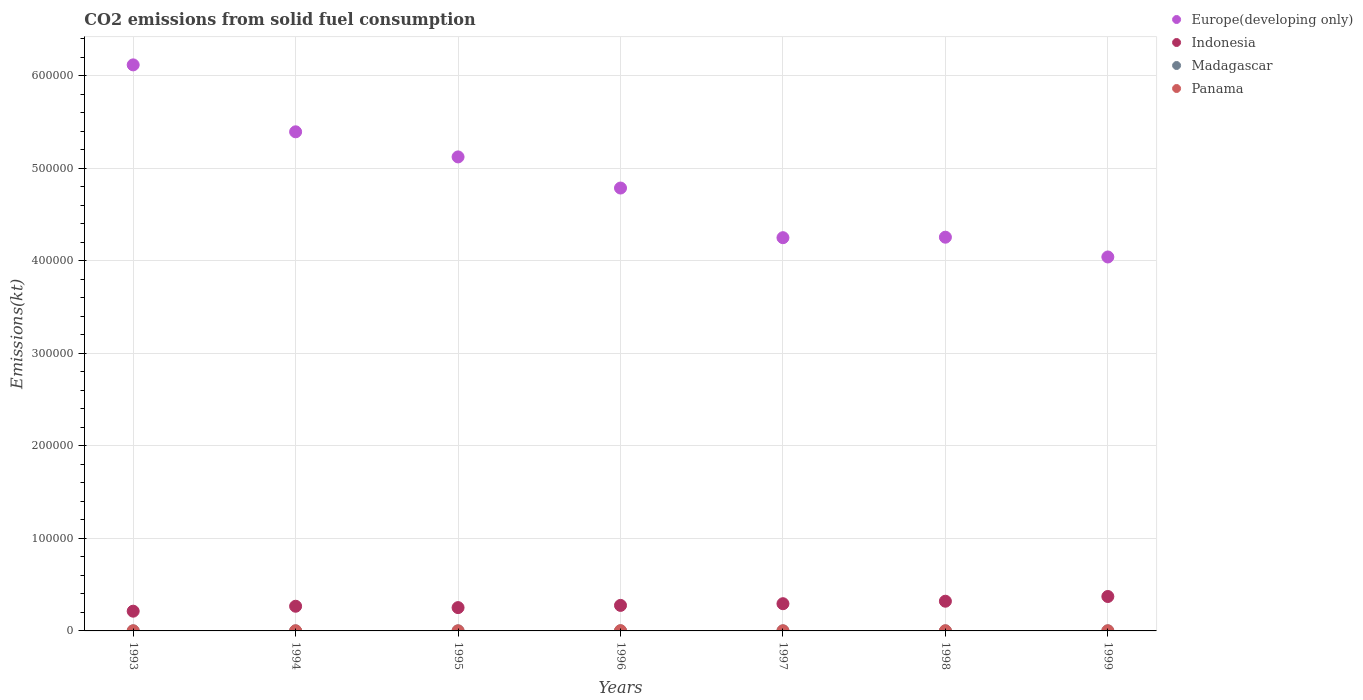How many different coloured dotlines are there?
Provide a succinct answer. 4. Is the number of dotlines equal to the number of legend labels?
Your answer should be compact. Yes. What is the amount of CO2 emitted in Panama in 1997?
Offer a very short reply. 150.35. Across all years, what is the maximum amount of CO2 emitted in Madagascar?
Offer a terse response. 36.67. Across all years, what is the minimum amount of CO2 emitted in Indonesia?
Your answer should be compact. 2.13e+04. In which year was the amount of CO2 emitted in Madagascar maximum?
Keep it short and to the point. 1993. In which year was the amount of CO2 emitted in Europe(developing only) minimum?
Give a very brief answer. 1999. What is the total amount of CO2 emitted in Panama in the graph?
Offer a terse response. 1107.43. What is the difference between the amount of CO2 emitted in Europe(developing only) in 1994 and that in 1999?
Your answer should be compact. 1.35e+05. What is the difference between the amount of CO2 emitted in Panama in 1998 and the amount of CO2 emitted in Europe(developing only) in 1996?
Offer a very short reply. -4.78e+05. What is the average amount of CO2 emitted in Indonesia per year?
Your answer should be compact. 2.85e+04. In the year 1995, what is the difference between the amount of CO2 emitted in Panama and amount of CO2 emitted in Indonesia?
Make the answer very short. -2.51e+04. What is the difference between the highest and the second highest amount of CO2 emitted in Indonesia?
Your answer should be very brief. 5097.13. What is the difference between the highest and the lowest amount of CO2 emitted in Indonesia?
Your answer should be compact. 1.59e+04. In how many years, is the amount of CO2 emitted in Panama greater than the average amount of CO2 emitted in Panama taken over all years?
Your response must be concise. 1. Is the sum of the amount of CO2 emitted in Madagascar in 1996 and 1999 greater than the maximum amount of CO2 emitted in Indonesia across all years?
Offer a terse response. No. Does the amount of CO2 emitted in Panama monotonically increase over the years?
Provide a succinct answer. No. Is the amount of CO2 emitted in Indonesia strictly greater than the amount of CO2 emitted in Madagascar over the years?
Your response must be concise. Yes. How many dotlines are there?
Provide a succinct answer. 4. Does the graph contain grids?
Keep it short and to the point. Yes. Where does the legend appear in the graph?
Ensure brevity in your answer.  Top right. What is the title of the graph?
Your answer should be compact. CO2 emissions from solid fuel consumption. Does "Tonga" appear as one of the legend labels in the graph?
Your answer should be compact. No. What is the label or title of the X-axis?
Your answer should be very brief. Years. What is the label or title of the Y-axis?
Your answer should be compact. Emissions(kt). What is the Emissions(kt) in Europe(developing only) in 1993?
Provide a short and direct response. 6.12e+05. What is the Emissions(kt) of Indonesia in 1993?
Keep it short and to the point. 2.13e+04. What is the Emissions(kt) of Madagascar in 1993?
Ensure brevity in your answer.  36.67. What is the Emissions(kt) of Panama in 1993?
Ensure brevity in your answer.  139.35. What is the Emissions(kt) in Europe(developing only) in 1994?
Provide a short and direct response. 5.39e+05. What is the Emissions(kt) of Indonesia in 1994?
Offer a terse response. 2.67e+04. What is the Emissions(kt) of Madagascar in 1994?
Your answer should be compact. 33. What is the Emissions(kt) in Panama in 1994?
Ensure brevity in your answer.  143.01. What is the Emissions(kt) of Europe(developing only) in 1995?
Offer a terse response. 5.12e+05. What is the Emissions(kt) of Indonesia in 1995?
Ensure brevity in your answer.  2.52e+04. What is the Emissions(kt) of Madagascar in 1995?
Ensure brevity in your answer.  25.67. What is the Emissions(kt) in Panama in 1995?
Ensure brevity in your answer.  95.34. What is the Emissions(kt) of Europe(developing only) in 1996?
Your answer should be compact. 4.79e+05. What is the Emissions(kt) of Indonesia in 1996?
Ensure brevity in your answer.  2.76e+04. What is the Emissions(kt) of Madagascar in 1996?
Make the answer very short. 25.67. What is the Emissions(kt) of Panama in 1996?
Provide a short and direct response. 264.02. What is the Emissions(kt) in Europe(developing only) in 1997?
Your answer should be compact. 4.25e+05. What is the Emissions(kt) in Indonesia in 1997?
Offer a terse response. 2.94e+04. What is the Emissions(kt) in Madagascar in 1997?
Provide a succinct answer. 33. What is the Emissions(kt) in Panama in 1997?
Provide a succinct answer. 150.35. What is the Emissions(kt) of Europe(developing only) in 1998?
Provide a short and direct response. 4.26e+05. What is the Emissions(kt) of Indonesia in 1998?
Offer a very short reply. 3.21e+04. What is the Emissions(kt) of Madagascar in 1998?
Your answer should be very brief. 33. What is the Emissions(kt) of Panama in 1998?
Your answer should be compact. 157.68. What is the Emissions(kt) in Europe(developing only) in 1999?
Keep it short and to the point. 4.04e+05. What is the Emissions(kt) of Indonesia in 1999?
Your answer should be compact. 3.72e+04. What is the Emissions(kt) of Madagascar in 1999?
Offer a terse response. 22. What is the Emissions(kt) of Panama in 1999?
Provide a succinct answer. 157.68. Across all years, what is the maximum Emissions(kt) in Europe(developing only)?
Provide a short and direct response. 6.12e+05. Across all years, what is the maximum Emissions(kt) in Indonesia?
Make the answer very short. 3.72e+04. Across all years, what is the maximum Emissions(kt) in Madagascar?
Keep it short and to the point. 36.67. Across all years, what is the maximum Emissions(kt) in Panama?
Provide a short and direct response. 264.02. Across all years, what is the minimum Emissions(kt) of Europe(developing only)?
Offer a very short reply. 4.04e+05. Across all years, what is the minimum Emissions(kt) of Indonesia?
Give a very brief answer. 2.13e+04. Across all years, what is the minimum Emissions(kt) in Madagascar?
Provide a succinct answer. 22. Across all years, what is the minimum Emissions(kt) in Panama?
Give a very brief answer. 95.34. What is the total Emissions(kt) in Europe(developing only) in the graph?
Offer a terse response. 3.40e+06. What is the total Emissions(kt) of Indonesia in the graph?
Offer a very short reply. 1.99e+05. What is the total Emissions(kt) of Madagascar in the graph?
Offer a terse response. 209.02. What is the total Emissions(kt) in Panama in the graph?
Your response must be concise. 1107.43. What is the difference between the Emissions(kt) of Europe(developing only) in 1993 and that in 1994?
Make the answer very short. 7.23e+04. What is the difference between the Emissions(kt) in Indonesia in 1993 and that in 1994?
Keep it short and to the point. -5342.82. What is the difference between the Emissions(kt) of Madagascar in 1993 and that in 1994?
Provide a succinct answer. 3.67. What is the difference between the Emissions(kt) in Panama in 1993 and that in 1994?
Your response must be concise. -3.67. What is the difference between the Emissions(kt) in Europe(developing only) in 1993 and that in 1995?
Ensure brevity in your answer.  9.95e+04. What is the difference between the Emissions(kt) of Indonesia in 1993 and that in 1995?
Make the answer very short. -3868.68. What is the difference between the Emissions(kt) in Madagascar in 1993 and that in 1995?
Offer a terse response. 11. What is the difference between the Emissions(kt) in Panama in 1993 and that in 1995?
Offer a terse response. 44. What is the difference between the Emissions(kt) in Europe(developing only) in 1993 and that in 1996?
Ensure brevity in your answer.  1.33e+05. What is the difference between the Emissions(kt) of Indonesia in 1993 and that in 1996?
Give a very brief answer. -6255.9. What is the difference between the Emissions(kt) of Madagascar in 1993 and that in 1996?
Your answer should be very brief. 11. What is the difference between the Emissions(kt) in Panama in 1993 and that in 1996?
Give a very brief answer. -124.68. What is the difference between the Emissions(kt) in Europe(developing only) in 1993 and that in 1997?
Your answer should be very brief. 1.87e+05. What is the difference between the Emissions(kt) in Indonesia in 1993 and that in 1997?
Offer a very short reply. -8085.73. What is the difference between the Emissions(kt) of Madagascar in 1993 and that in 1997?
Give a very brief answer. 3.67. What is the difference between the Emissions(kt) of Panama in 1993 and that in 1997?
Your answer should be very brief. -11. What is the difference between the Emissions(kt) in Europe(developing only) in 1993 and that in 1998?
Provide a succinct answer. 1.86e+05. What is the difference between the Emissions(kt) in Indonesia in 1993 and that in 1998?
Keep it short and to the point. -1.08e+04. What is the difference between the Emissions(kt) in Madagascar in 1993 and that in 1998?
Ensure brevity in your answer.  3.67. What is the difference between the Emissions(kt) of Panama in 1993 and that in 1998?
Your answer should be compact. -18.34. What is the difference between the Emissions(kt) in Europe(developing only) in 1993 and that in 1999?
Offer a terse response. 2.08e+05. What is the difference between the Emissions(kt) of Indonesia in 1993 and that in 1999?
Ensure brevity in your answer.  -1.59e+04. What is the difference between the Emissions(kt) in Madagascar in 1993 and that in 1999?
Keep it short and to the point. 14.67. What is the difference between the Emissions(kt) in Panama in 1993 and that in 1999?
Your answer should be very brief. -18.34. What is the difference between the Emissions(kt) in Europe(developing only) in 1994 and that in 1995?
Offer a terse response. 2.71e+04. What is the difference between the Emissions(kt) in Indonesia in 1994 and that in 1995?
Offer a terse response. 1474.13. What is the difference between the Emissions(kt) of Madagascar in 1994 and that in 1995?
Keep it short and to the point. 7.33. What is the difference between the Emissions(kt) of Panama in 1994 and that in 1995?
Keep it short and to the point. 47.67. What is the difference between the Emissions(kt) of Europe(developing only) in 1994 and that in 1996?
Provide a short and direct response. 6.08e+04. What is the difference between the Emissions(kt) in Indonesia in 1994 and that in 1996?
Provide a succinct answer. -913.08. What is the difference between the Emissions(kt) of Madagascar in 1994 and that in 1996?
Ensure brevity in your answer.  7.33. What is the difference between the Emissions(kt) of Panama in 1994 and that in 1996?
Provide a succinct answer. -121.01. What is the difference between the Emissions(kt) of Europe(developing only) in 1994 and that in 1997?
Your response must be concise. 1.14e+05. What is the difference between the Emissions(kt) of Indonesia in 1994 and that in 1997?
Make the answer very short. -2742.92. What is the difference between the Emissions(kt) in Madagascar in 1994 and that in 1997?
Provide a short and direct response. 0. What is the difference between the Emissions(kt) in Panama in 1994 and that in 1997?
Your response must be concise. -7.33. What is the difference between the Emissions(kt) of Europe(developing only) in 1994 and that in 1998?
Keep it short and to the point. 1.14e+05. What is the difference between the Emissions(kt) of Indonesia in 1994 and that in 1998?
Give a very brief answer. -5430.83. What is the difference between the Emissions(kt) in Panama in 1994 and that in 1998?
Make the answer very short. -14.67. What is the difference between the Emissions(kt) of Europe(developing only) in 1994 and that in 1999?
Your answer should be compact. 1.35e+05. What is the difference between the Emissions(kt) of Indonesia in 1994 and that in 1999?
Offer a very short reply. -1.05e+04. What is the difference between the Emissions(kt) of Madagascar in 1994 and that in 1999?
Give a very brief answer. 11. What is the difference between the Emissions(kt) of Panama in 1994 and that in 1999?
Give a very brief answer. -14.67. What is the difference between the Emissions(kt) in Europe(developing only) in 1995 and that in 1996?
Keep it short and to the point. 3.36e+04. What is the difference between the Emissions(kt) in Indonesia in 1995 and that in 1996?
Make the answer very short. -2387.22. What is the difference between the Emissions(kt) of Madagascar in 1995 and that in 1996?
Your answer should be very brief. 0. What is the difference between the Emissions(kt) of Panama in 1995 and that in 1996?
Keep it short and to the point. -168.68. What is the difference between the Emissions(kt) in Europe(developing only) in 1995 and that in 1997?
Make the answer very short. 8.73e+04. What is the difference between the Emissions(kt) in Indonesia in 1995 and that in 1997?
Provide a succinct answer. -4217.05. What is the difference between the Emissions(kt) of Madagascar in 1995 and that in 1997?
Ensure brevity in your answer.  -7.33. What is the difference between the Emissions(kt) of Panama in 1995 and that in 1997?
Give a very brief answer. -55.01. What is the difference between the Emissions(kt) in Europe(developing only) in 1995 and that in 1998?
Offer a terse response. 8.68e+04. What is the difference between the Emissions(kt) of Indonesia in 1995 and that in 1998?
Make the answer very short. -6904.96. What is the difference between the Emissions(kt) of Madagascar in 1995 and that in 1998?
Your answer should be very brief. -7.33. What is the difference between the Emissions(kt) in Panama in 1995 and that in 1998?
Provide a succinct answer. -62.34. What is the difference between the Emissions(kt) of Europe(developing only) in 1995 and that in 1999?
Offer a very short reply. 1.08e+05. What is the difference between the Emissions(kt) of Indonesia in 1995 and that in 1999?
Your response must be concise. -1.20e+04. What is the difference between the Emissions(kt) of Madagascar in 1995 and that in 1999?
Ensure brevity in your answer.  3.67. What is the difference between the Emissions(kt) of Panama in 1995 and that in 1999?
Make the answer very short. -62.34. What is the difference between the Emissions(kt) of Europe(developing only) in 1996 and that in 1997?
Your answer should be compact. 5.37e+04. What is the difference between the Emissions(kt) in Indonesia in 1996 and that in 1997?
Offer a very short reply. -1829.83. What is the difference between the Emissions(kt) in Madagascar in 1996 and that in 1997?
Make the answer very short. -7.33. What is the difference between the Emissions(kt) of Panama in 1996 and that in 1997?
Provide a succinct answer. 113.68. What is the difference between the Emissions(kt) in Europe(developing only) in 1996 and that in 1998?
Your answer should be compact. 5.31e+04. What is the difference between the Emissions(kt) of Indonesia in 1996 and that in 1998?
Your response must be concise. -4517.74. What is the difference between the Emissions(kt) of Madagascar in 1996 and that in 1998?
Provide a succinct answer. -7.33. What is the difference between the Emissions(kt) of Panama in 1996 and that in 1998?
Keep it short and to the point. 106.34. What is the difference between the Emissions(kt) of Europe(developing only) in 1996 and that in 1999?
Keep it short and to the point. 7.45e+04. What is the difference between the Emissions(kt) of Indonesia in 1996 and that in 1999?
Provide a succinct answer. -9614.87. What is the difference between the Emissions(kt) in Madagascar in 1996 and that in 1999?
Your answer should be very brief. 3.67. What is the difference between the Emissions(kt) of Panama in 1996 and that in 1999?
Provide a short and direct response. 106.34. What is the difference between the Emissions(kt) in Europe(developing only) in 1997 and that in 1998?
Make the answer very short. -528.25. What is the difference between the Emissions(kt) of Indonesia in 1997 and that in 1998?
Offer a very short reply. -2687.91. What is the difference between the Emissions(kt) of Panama in 1997 and that in 1998?
Offer a very short reply. -7.33. What is the difference between the Emissions(kt) of Europe(developing only) in 1997 and that in 1999?
Offer a terse response. 2.09e+04. What is the difference between the Emissions(kt) of Indonesia in 1997 and that in 1999?
Ensure brevity in your answer.  -7785.04. What is the difference between the Emissions(kt) of Madagascar in 1997 and that in 1999?
Keep it short and to the point. 11. What is the difference between the Emissions(kt) of Panama in 1997 and that in 1999?
Keep it short and to the point. -7.33. What is the difference between the Emissions(kt) of Europe(developing only) in 1998 and that in 1999?
Offer a terse response. 2.14e+04. What is the difference between the Emissions(kt) in Indonesia in 1998 and that in 1999?
Keep it short and to the point. -5097.13. What is the difference between the Emissions(kt) in Madagascar in 1998 and that in 1999?
Ensure brevity in your answer.  11. What is the difference between the Emissions(kt) of Panama in 1998 and that in 1999?
Your response must be concise. 0. What is the difference between the Emissions(kt) in Europe(developing only) in 1993 and the Emissions(kt) in Indonesia in 1994?
Make the answer very short. 5.85e+05. What is the difference between the Emissions(kt) in Europe(developing only) in 1993 and the Emissions(kt) in Madagascar in 1994?
Your answer should be very brief. 6.12e+05. What is the difference between the Emissions(kt) in Europe(developing only) in 1993 and the Emissions(kt) in Panama in 1994?
Your response must be concise. 6.12e+05. What is the difference between the Emissions(kt) of Indonesia in 1993 and the Emissions(kt) of Madagascar in 1994?
Your answer should be very brief. 2.13e+04. What is the difference between the Emissions(kt) in Indonesia in 1993 and the Emissions(kt) in Panama in 1994?
Keep it short and to the point. 2.12e+04. What is the difference between the Emissions(kt) of Madagascar in 1993 and the Emissions(kt) of Panama in 1994?
Make the answer very short. -106.34. What is the difference between the Emissions(kt) in Europe(developing only) in 1993 and the Emissions(kt) in Indonesia in 1995?
Ensure brevity in your answer.  5.87e+05. What is the difference between the Emissions(kt) of Europe(developing only) in 1993 and the Emissions(kt) of Madagascar in 1995?
Ensure brevity in your answer.  6.12e+05. What is the difference between the Emissions(kt) of Europe(developing only) in 1993 and the Emissions(kt) of Panama in 1995?
Offer a very short reply. 6.12e+05. What is the difference between the Emissions(kt) in Indonesia in 1993 and the Emissions(kt) in Madagascar in 1995?
Give a very brief answer. 2.13e+04. What is the difference between the Emissions(kt) of Indonesia in 1993 and the Emissions(kt) of Panama in 1995?
Ensure brevity in your answer.  2.12e+04. What is the difference between the Emissions(kt) of Madagascar in 1993 and the Emissions(kt) of Panama in 1995?
Offer a terse response. -58.67. What is the difference between the Emissions(kt) in Europe(developing only) in 1993 and the Emissions(kt) in Indonesia in 1996?
Offer a very short reply. 5.84e+05. What is the difference between the Emissions(kt) of Europe(developing only) in 1993 and the Emissions(kt) of Madagascar in 1996?
Provide a succinct answer. 6.12e+05. What is the difference between the Emissions(kt) in Europe(developing only) in 1993 and the Emissions(kt) in Panama in 1996?
Keep it short and to the point. 6.11e+05. What is the difference between the Emissions(kt) of Indonesia in 1993 and the Emissions(kt) of Madagascar in 1996?
Make the answer very short. 2.13e+04. What is the difference between the Emissions(kt) in Indonesia in 1993 and the Emissions(kt) in Panama in 1996?
Keep it short and to the point. 2.11e+04. What is the difference between the Emissions(kt) in Madagascar in 1993 and the Emissions(kt) in Panama in 1996?
Ensure brevity in your answer.  -227.35. What is the difference between the Emissions(kt) of Europe(developing only) in 1993 and the Emissions(kt) of Indonesia in 1997?
Your answer should be compact. 5.82e+05. What is the difference between the Emissions(kt) in Europe(developing only) in 1993 and the Emissions(kt) in Madagascar in 1997?
Give a very brief answer. 6.12e+05. What is the difference between the Emissions(kt) in Europe(developing only) in 1993 and the Emissions(kt) in Panama in 1997?
Ensure brevity in your answer.  6.12e+05. What is the difference between the Emissions(kt) in Indonesia in 1993 and the Emissions(kt) in Madagascar in 1997?
Ensure brevity in your answer.  2.13e+04. What is the difference between the Emissions(kt) of Indonesia in 1993 and the Emissions(kt) of Panama in 1997?
Offer a terse response. 2.12e+04. What is the difference between the Emissions(kt) of Madagascar in 1993 and the Emissions(kt) of Panama in 1997?
Make the answer very short. -113.68. What is the difference between the Emissions(kt) of Europe(developing only) in 1993 and the Emissions(kt) of Indonesia in 1998?
Your response must be concise. 5.80e+05. What is the difference between the Emissions(kt) of Europe(developing only) in 1993 and the Emissions(kt) of Madagascar in 1998?
Give a very brief answer. 6.12e+05. What is the difference between the Emissions(kt) in Europe(developing only) in 1993 and the Emissions(kt) in Panama in 1998?
Ensure brevity in your answer.  6.12e+05. What is the difference between the Emissions(kt) in Indonesia in 1993 and the Emissions(kt) in Madagascar in 1998?
Ensure brevity in your answer.  2.13e+04. What is the difference between the Emissions(kt) in Indonesia in 1993 and the Emissions(kt) in Panama in 1998?
Provide a succinct answer. 2.12e+04. What is the difference between the Emissions(kt) in Madagascar in 1993 and the Emissions(kt) in Panama in 1998?
Provide a short and direct response. -121.01. What is the difference between the Emissions(kt) in Europe(developing only) in 1993 and the Emissions(kt) in Indonesia in 1999?
Provide a succinct answer. 5.75e+05. What is the difference between the Emissions(kt) in Europe(developing only) in 1993 and the Emissions(kt) in Madagascar in 1999?
Offer a very short reply. 6.12e+05. What is the difference between the Emissions(kt) of Europe(developing only) in 1993 and the Emissions(kt) of Panama in 1999?
Provide a succinct answer. 6.12e+05. What is the difference between the Emissions(kt) in Indonesia in 1993 and the Emissions(kt) in Madagascar in 1999?
Your response must be concise. 2.13e+04. What is the difference between the Emissions(kt) of Indonesia in 1993 and the Emissions(kt) of Panama in 1999?
Your response must be concise. 2.12e+04. What is the difference between the Emissions(kt) in Madagascar in 1993 and the Emissions(kt) in Panama in 1999?
Your answer should be compact. -121.01. What is the difference between the Emissions(kt) in Europe(developing only) in 1994 and the Emissions(kt) in Indonesia in 1995?
Offer a very short reply. 5.14e+05. What is the difference between the Emissions(kt) of Europe(developing only) in 1994 and the Emissions(kt) of Madagascar in 1995?
Provide a succinct answer. 5.39e+05. What is the difference between the Emissions(kt) in Europe(developing only) in 1994 and the Emissions(kt) in Panama in 1995?
Give a very brief answer. 5.39e+05. What is the difference between the Emissions(kt) of Indonesia in 1994 and the Emissions(kt) of Madagascar in 1995?
Ensure brevity in your answer.  2.66e+04. What is the difference between the Emissions(kt) in Indonesia in 1994 and the Emissions(kt) in Panama in 1995?
Your answer should be very brief. 2.66e+04. What is the difference between the Emissions(kt) of Madagascar in 1994 and the Emissions(kt) of Panama in 1995?
Keep it short and to the point. -62.34. What is the difference between the Emissions(kt) in Europe(developing only) in 1994 and the Emissions(kt) in Indonesia in 1996?
Ensure brevity in your answer.  5.12e+05. What is the difference between the Emissions(kt) of Europe(developing only) in 1994 and the Emissions(kt) of Madagascar in 1996?
Give a very brief answer. 5.39e+05. What is the difference between the Emissions(kt) in Europe(developing only) in 1994 and the Emissions(kt) in Panama in 1996?
Your answer should be very brief. 5.39e+05. What is the difference between the Emissions(kt) in Indonesia in 1994 and the Emissions(kt) in Madagascar in 1996?
Make the answer very short. 2.66e+04. What is the difference between the Emissions(kt) of Indonesia in 1994 and the Emissions(kt) of Panama in 1996?
Offer a very short reply. 2.64e+04. What is the difference between the Emissions(kt) of Madagascar in 1994 and the Emissions(kt) of Panama in 1996?
Make the answer very short. -231.02. What is the difference between the Emissions(kt) in Europe(developing only) in 1994 and the Emissions(kt) in Indonesia in 1997?
Give a very brief answer. 5.10e+05. What is the difference between the Emissions(kt) in Europe(developing only) in 1994 and the Emissions(kt) in Madagascar in 1997?
Ensure brevity in your answer.  5.39e+05. What is the difference between the Emissions(kt) in Europe(developing only) in 1994 and the Emissions(kt) in Panama in 1997?
Offer a terse response. 5.39e+05. What is the difference between the Emissions(kt) of Indonesia in 1994 and the Emissions(kt) of Madagascar in 1997?
Provide a short and direct response. 2.66e+04. What is the difference between the Emissions(kt) in Indonesia in 1994 and the Emissions(kt) in Panama in 1997?
Provide a short and direct response. 2.65e+04. What is the difference between the Emissions(kt) in Madagascar in 1994 and the Emissions(kt) in Panama in 1997?
Provide a succinct answer. -117.34. What is the difference between the Emissions(kt) of Europe(developing only) in 1994 and the Emissions(kt) of Indonesia in 1998?
Give a very brief answer. 5.07e+05. What is the difference between the Emissions(kt) in Europe(developing only) in 1994 and the Emissions(kt) in Madagascar in 1998?
Keep it short and to the point. 5.39e+05. What is the difference between the Emissions(kt) in Europe(developing only) in 1994 and the Emissions(kt) in Panama in 1998?
Offer a very short reply. 5.39e+05. What is the difference between the Emissions(kt) of Indonesia in 1994 and the Emissions(kt) of Madagascar in 1998?
Provide a short and direct response. 2.66e+04. What is the difference between the Emissions(kt) of Indonesia in 1994 and the Emissions(kt) of Panama in 1998?
Offer a very short reply. 2.65e+04. What is the difference between the Emissions(kt) in Madagascar in 1994 and the Emissions(kt) in Panama in 1998?
Your answer should be very brief. -124.68. What is the difference between the Emissions(kt) of Europe(developing only) in 1994 and the Emissions(kt) of Indonesia in 1999?
Your response must be concise. 5.02e+05. What is the difference between the Emissions(kt) of Europe(developing only) in 1994 and the Emissions(kt) of Madagascar in 1999?
Provide a short and direct response. 5.39e+05. What is the difference between the Emissions(kt) in Europe(developing only) in 1994 and the Emissions(kt) in Panama in 1999?
Your answer should be very brief. 5.39e+05. What is the difference between the Emissions(kt) of Indonesia in 1994 and the Emissions(kt) of Madagascar in 1999?
Offer a terse response. 2.66e+04. What is the difference between the Emissions(kt) in Indonesia in 1994 and the Emissions(kt) in Panama in 1999?
Ensure brevity in your answer.  2.65e+04. What is the difference between the Emissions(kt) in Madagascar in 1994 and the Emissions(kt) in Panama in 1999?
Give a very brief answer. -124.68. What is the difference between the Emissions(kt) of Europe(developing only) in 1995 and the Emissions(kt) of Indonesia in 1996?
Offer a terse response. 4.85e+05. What is the difference between the Emissions(kt) in Europe(developing only) in 1995 and the Emissions(kt) in Madagascar in 1996?
Your answer should be compact. 5.12e+05. What is the difference between the Emissions(kt) of Europe(developing only) in 1995 and the Emissions(kt) of Panama in 1996?
Offer a very short reply. 5.12e+05. What is the difference between the Emissions(kt) in Indonesia in 1995 and the Emissions(kt) in Madagascar in 1996?
Provide a short and direct response. 2.52e+04. What is the difference between the Emissions(kt) in Indonesia in 1995 and the Emissions(kt) in Panama in 1996?
Ensure brevity in your answer.  2.49e+04. What is the difference between the Emissions(kt) of Madagascar in 1995 and the Emissions(kt) of Panama in 1996?
Ensure brevity in your answer.  -238.35. What is the difference between the Emissions(kt) of Europe(developing only) in 1995 and the Emissions(kt) of Indonesia in 1997?
Keep it short and to the point. 4.83e+05. What is the difference between the Emissions(kt) in Europe(developing only) in 1995 and the Emissions(kt) in Madagascar in 1997?
Make the answer very short. 5.12e+05. What is the difference between the Emissions(kt) in Europe(developing only) in 1995 and the Emissions(kt) in Panama in 1997?
Ensure brevity in your answer.  5.12e+05. What is the difference between the Emissions(kt) of Indonesia in 1995 and the Emissions(kt) of Madagascar in 1997?
Make the answer very short. 2.52e+04. What is the difference between the Emissions(kt) of Indonesia in 1995 and the Emissions(kt) of Panama in 1997?
Ensure brevity in your answer.  2.50e+04. What is the difference between the Emissions(kt) of Madagascar in 1995 and the Emissions(kt) of Panama in 1997?
Keep it short and to the point. -124.68. What is the difference between the Emissions(kt) of Europe(developing only) in 1995 and the Emissions(kt) of Indonesia in 1998?
Provide a succinct answer. 4.80e+05. What is the difference between the Emissions(kt) of Europe(developing only) in 1995 and the Emissions(kt) of Madagascar in 1998?
Your answer should be very brief. 5.12e+05. What is the difference between the Emissions(kt) in Europe(developing only) in 1995 and the Emissions(kt) in Panama in 1998?
Provide a short and direct response. 5.12e+05. What is the difference between the Emissions(kt) in Indonesia in 1995 and the Emissions(kt) in Madagascar in 1998?
Keep it short and to the point. 2.52e+04. What is the difference between the Emissions(kt) in Indonesia in 1995 and the Emissions(kt) in Panama in 1998?
Ensure brevity in your answer.  2.50e+04. What is the difference between the Emissions(kt) in Madagascar in 1995 and the Emissions(kt) in Panama in 1998?
Your response must be concise. -132.01. What is the difference between the Emissions(kt) in Europe(developing only) in 1995 and the Emissions(kt) in Indonesia in 1999?
Provide a succinct answer. 4.75e+05. What is the difference between the Emissions(kt) in Europe(developing only) in 1995 and the Emissions(kt) in Madagascar in 1999?
Provide a succinct answer. 5.12e+05. What is the difference between the Emissions(kt) in Europe(developing only) in 1995 and the Emissions(kt) in Panama in 1999?
Keep it short and to the point. 5.12e+05. What is the difference between the Emissions(kt) in Indonesia in 1995 and the Emissions(kt) in Madagascar in 1999?
Provide a succinct answer. 2.52e+04. What is the difference between the Emissions(kt) in Indonesia in 1995 and the Emissions(kt) in Panama in 1999?
Your answer should be very brief. 2.50e+04. What is the difference between the Emissions(kt) of Madagascar in 1995 and the Emissions(kt) of Panama in 1999?
Ensure brevity in your answer.  -132.01. What is the difference between the Emissions(kt) in Europe(developing only) in 1996 and the Emissions(kt) in Indonesia in 1997?
Offer a very short reply. 4.49e+05. What is the difference between the Emissions(kt) of Europe(developing only) in 1996 and the Emissions(kt) of Madagascar in 1997?
Your answer should be compact. 4.79e+05. What is the difference between the Emissions(kt) in Europe(developing only) in 1996 and the Emissions(kt) in Panama in 1997?
Ensure brevity in your answer.  4.78e+05. What is the difference between the Emissions(kt) of Indonesia in 1996 and the Emissions(kt) of Madagascar in 1997?
Provide a succinct answer. 2.76e+04. What is the difference between the Emissions(kt) in Indonesia in 1996 and the Emissions(kt) in Panama in 1997?
Provide a succinct answer. 2.74e+04. What is the difference between the Emissions(kt) in Madagascar in 1996 and the Emissions(kt) in Panama in 1997?
Make the answer very short. -124.68. What is the difference between the Emissions(kt) in Europe(developing only) in 1996 and the Emissions(kt) in Indonesia in 1998?
Your answer should be very brief. 4.47e+05. What is the difference between the Emissions(kt) of Europe(developing only) in 1996 and the Emissions(kt) of Madagascar in 1998?
Make the answer very short. 4.79e+05. What is the difference between the Emissions(kt) in Europe(developing only) in 1996 and the Emissions(kt) in Panama in 1998?
Your answer should be very brief. 4.78e+05. What is the difference between the Emissions(kt) of Indonesia in 1996 and the Emissions(kt) of Madagascar in 1998?
Provide a succinct answer. 2.76e+04. What is the difference between the Emissions(kt) of Indonesia in 1996 and the Emissions(kt) of Panama in 1998?
Provide a short and direct response. 2.74e+04. What is the difference between the Emissions(kt) of Madagascar in 1996 and the Emissions(kt) of Panama in 1998?
Make the answer very short. -132.01. What is the difference between the Emissions(kt) in Europe(developing only) in 1996 and the Emissions(kt) in Indonesia in 1999?
Your answer should be very brief. 4.41e+05. What is the difference between the Emissions(kt) in Europe(developing only) in 1996 and the Emissions(kt) in Madagascar in 1999?
Keep it short and to the point. 4.79e+05. What is the difference between the Emissions(kt) in Europe(developing only) in 1996 and the Emissions(kt) in Panama in 1999?
Your response must be concise. 4.78e+05. What is the difference between the Emissions(kt) of Indonesia in 1996 and the Emissions(kt) of Madagascar in 1999?
Provide a succinct answer. 2.76e+04. What is the difference between the Emissions(kt) of Indonesia in 1996 and the Emissions(kt) of Panama in 1999?
Offer a terse response. 2.74e+04. What is the difference between the Emissions(kt) of Madagascar in 1996 and the Emissions(kt) of Panama in 1999?
Offer a terse response. -132.01. What is the difference between the Emissions(kt) in Europe(developing only) in 1997 and the Emissions(kt) in Indonesia in 1998?
Offer a terse response. 3.93e+05. What is the difference between the Emissions(kt) in Europe(developing only) in 1997 and the Emissions(kt) in Madagascar in 1998?
Provide a short and direct response. 4.25e+05. What is the difference between the Emissions(kt) in Europe(developing only) in 1997 and the Emissions(kt) in Panama in 1998?
Your answer should be compact. 4.25e+05. What is the difference between the Emissions(kt) in Indonesia in 1997 and the Emissions(kt) in Madagascar in 1998?
Ensure brevity in your answer.  2.94e+04. What is the difference between the Emissions(kt) in Indonesia in 1997 and the Emissions(kt) in Panama in 1998?
Provide a succinct answer. 2.93e+04. What is the difference between the Emissions(kt) in Madagascar in 1997 and the Emissions(kt) in Panama in 1998?
Provide a succinct answer. -124.68. What is the difference between the Emissions(kt) in Europe(developing only) in 1997 and the Emissions(kt) in Indonesia in 1999?
Your response must be concise. 3.88e+05. What is the difference between the Emissions(kt) in Europe(developing only) in 1997 and the Emissions(kt) in Madagascar in 1999?
Make the answer very short. 4.25e+05. What is the difference between the Emissions(kt) in Europe(developing only) in 1997 and the Emissions(kt) in Panama in 1999?
Offer a terse response. 4.25e+05. What is the difference between the Emissions(kt) of Indonesia in 1997 and the Emissions(kt) of Madagascar in 1999?
Your response must be concise. 2.94e+04. What is the difference between the Emissions(kt) in Indonesia in 1997 and the Emissions(kt) in Panama in 1999?
Make the answer very short. 2.93e+04. What is the difference between the Emissions(kt) of Madagascar in 1997 and the Emissions(kt) of Panama in 1999?
Offer a terse response. -124.68. What is the difference between the Emissions(kt) of Europe(developing only) in 1998 and the Emissions(kt) of Indonesia in 1999?
Provide a succinct answer. 3.88e+05. What is the difference between the Emissions(kt) of Europe(developing only) in 1998 and the Emissions(kt) of Madagascar in 1999?
Your response must be concise. 4.25e+05. What is the difference between the Emissions(kt) in Europe(developing only) in 1998 and the Emissions(kt) in Panama in 1999?
Your answer should be compact. 4.25e+05. What is the difference between the Emissions(kt) in Indonesia in 1998 and the Emissions(kt) in Madagascar in 1999?
Keep it short and to the point. 3.21e+04. What is the difference between the Emissions(kt) of Indonesia in 1998 and the Emissions(kt) of Panama in 1999?
Your response must be concise. 3.19e+04. What is the difference between the Emissions(kt) in Madagascar in 1998 and the Emissions(kt) in Panama in 1999?
Your answer should be compact. -124.68. What is the average Emissions(kt) of Europe(developing only) per year?
Make the answer very short. 4.85e+05. What is the average Emissions(kt) in Indonesia per year?
Make the answer very short. 2.85e+04. What is the average Emissions(kt) in Madagascar per year?
Your answer should be compact. 29.86. What is the average Emissions(kt) in Panama per year?
Offer a terse response. 158.2. In the year 1993, what is the difference between the Emissions(kt) of Europe(developing only) and Emissions(kt) of Indonesia?
Your answer should be compact. 5.90e+05. In the year 1993, what is the difference between the Emissions(kt) in Europe(developing only) and Emissions(kt) in Madagascar?
Keep it short and to the point. 6.12e+05. In the year 1993, what is the difference between the Emissions(kt) in Europe(developing only) and Emissions(kt) in Panama?
Offer a terse response. 6.12e+05. In the year 1993, what is the difference between the Emissions(kt) of Indonesia and Emissions(kt) of Madagascar?
Offer a terse response. 2.13e+04. In the year 1993, what is the difference between the Emissions(kt) of Indonesia and Emissions(kt) of Panama?
Provide a succinct answer. 2.12e+04. In the year 1993, what is the difference between the Emissions(kt) of Madagascar and Emissions(kt) of Panama?
Offer a very short reply. -102.68. In the year 1994, what is the difference between the Emissions(kt) of Europe(developing only) and Emissions(kt) of Indonesia?
Ensure brevity in your answer.  5.13e+05. In the year 1994, what is the difference between the Emissions(kt) of Europe(developing only) and Emissions(kt) of Madagascar?
Keep it short and to the point. 5.39e+05. In the year 1994, what is the difference between the Emissions(kt) of Europe(developing only) and Emissions(kt) of Panama?
Your response must be concise. 5.39e+05. In the year 1994, what is the difference between the Emissions(kt) in Indonesia and Emissions(kt) in Madagascar?
Give a very brief answer. 2.66e+04. In the year 1994, what is the difference between the Emissions(kt) of Indonesia and Emissions(kt) of Panama?
Your response must be concise. 2.65e+04. In the year 1994, what is the difference between the Emissions(kt) in Madagascar and Emissions(kt) in Panama?
Provide a short and direct response. -110.01. In the year 1995, what is the difference between the Emissions(kt) of Europe(developing only) and Emissions(kt) of Indonesia?
Your response must be concise. 4.87e+05. In the year 1995, what is the difference between the Emissions(kt) of Europe(developing only) and Emissions(kt) of Madagascar?
Your response must be concise. 5.12e+05. In the year 1995, what is the difference between the Emissions(kt) of Europe(developing only) and Emissions(kt) of Panama?
Offer a very short reply. 5.12e+05. In the year 1995, what is the difference between the Emissions(kt) in Indonesia and Emissions(kt) in Madagascar?
Give a very brief answer. 2.52e+04. In the year 1995, what is the difference between the Emissions(kt) of Indonesia and Emissions(kt) of Panama?
Your answer should be compact. 2.51e+04. In the year 1995, what is the difference between the Emissions(kt) of Madagascar and Emissions(kt) of Panama?
Keep it short and to the point. -69.67. In the year 1996, what is the difference between the Emissions(kt) of Europe(developing only) and Emissions(kt) of Indonesia?
Offer a very short reply. 4.51e+05. In the year 1996, what is the difference between the Emissions(kt) in Europe(developing only) and Emissions(kt) in Madagascar?
Your answer should be compact. 4.79e+05. In the year 1996, what is the difference between the Emissions(kt) in Europe(developing only) and Emissions(kt) in Panama?
Your answer should be compact. 4.78e+05. In the year 1996, what is the difference between the Emissions(kt) of Indonesia and Emissions(kt) of Madagascar?
Ensure brevity in your answer.  2.76e+04. In the year 1996, what is the difference between the Emissions(kt) of Indonesia and Emissions(kt) of Panama?
Make the answer very short. 2.73e+04. In the year 1996, what is the difference between the Emissions(kt) in Madagascar and Emissions(kt) in Panama?
Offer a terse response. -238.35. In the year 1997, what is the difference between the Emissions(kt) of Europe(developing only) and Emissions(kt) of Indonesia?
Your response must be concise. 3.96e+05. In the year 1997, what is the difference between the Emissions(kt) of Europe(developing only) and Emissions(kt) of Madagascar?
Provide a succinct answer. 4.25e+05. In the year 1997, what is the difference between the Emissions(kt) in Europe(developing only) and Emissions(kt) in Panama?
Make the answer very short. 4.25e+05. In the year 1997, what is the difference between the Emissions(kt) of Indonesia and Emissions(kt) of Madagascar?
Ensure brevity in your answer.  2.94e+04. In the year 1997, what is the difference between the Emissions(kt) in Indonesia and Emissions(kt) in Panama?
Ensure brevity in your answer.  2.93e+04. In the year 1997, what is the difference between the Emissions(kt) in Madagascar and Emissions(kt) in Panama?
Offer a terse response. -117.34. In the year 1998, what is the difference between the Emissions(kt) in Europe(developing only) and Emissions(kt) in Indonesia?
Ensure brevity in your answer.  3.93e+05. In the year 1998, what is the difference between the Emissions(kt) in Europe(developing only) and Emissions(kt) in Madagascar?
Make the answer very short. 4.25e+05. In the year 1998, what is the difference between the Emissions(kt) of Europe(developing only) and Emissions(kt) of Panama?
Provide a succinct answer. 4.25e+05. In the year 1998, what is the difference between the Emissions(kt) in Indonesia and Emissions(kt) in Madagascar?
Give a very brief answer. 3.21e+04. In the year 1998, what is the difference between the Emissions(kt) of Indonesia and Emissions(kt) of Panama?
Make the answer very short. 3.19e+04. In the year 1998, what is the difference between the Emissions(kt) in Madagascar and Emissions(kt) in Panama?
Keep it short and to the point. -124.68. In the year 1999, what is the difference between the Emissions(kt) in Europe(developing only) and Emissions(kt) in Indonesia?
Make the answer very short. 3.67e+05. In the year 1999, what is the difference between the Emissions(kt) in Europe(developing only) and Emissions(kt) in Madagascar?
Provide a short and direct response. 4.04e+05. In the year 1999, what is the difference between the Emissions(kt) of Europe(developing only) and Emissions(kt) of Panama?
Offer a terse response. 4.04e+05. In the year 1999, what is the difference between the Emissions(kt) in Indonesia and Emissions(kt) in Madagascar?
Your answer should be compact. 3.72e+04. In the year 1999, what is the difference between the Emissions(kt) in Indonesia and Emissions(kt) in Panama?
Keep it short and to the point. 3.70e+04. In the year 1999, what is the difference between the Emissions(kt) in Madagascar and Emissions(kt) in Panama?
Keep it short and to the point. -135.68. What is the ratio of the Emissions(kt) of Europe(developing only) in 1993 to that in 1994?
Keep it short and to the point. 1.13. What is the ratio of the Emissions(kt) in Indonesia in 1993 to that in 1994?
Offer a very short reply. 0.8. What is the ratio of the Emissions(kt) of Panama in 1993 to that in 1994?
Your answer should be very brief. 0.97. What is the ratio of the Emissions(kt) of Europe(developing only) in 1993 to that in 1995?
Ensure brevity in your answer.  1.19. What is the ratio of the Emissions(kt) of Indonesia in 1993 to that in 1995?
Provide a succinct answer. 0.85. What is the ratio of the Emissions(kt) of Madagascar in 1993 to that in 1995?
Offer a terse response. 1.43. What is the ratio of the Emissions(kt) in Panama in 1993 to that in 1995?
Your response must be concise. 1.46. What is the ratio of the Emissions(kt) of Europe(developing only) in 1993 to that in 1996?
Give a very brief answer. 1.28. What is the ratio of the Emissions(kt) of Indonesia in 1993 to that in 1996?
Keep it short and to the point. 0.77. What is the ratio of the Emissions(kt) of Madagascar in 1993 to that in 1996?
Your answer should be very brief. 1.43. What is the ratio of the Emissions(kt) of Panama in 1993 to that in 1996?
Your answer should be compact. 0.53. What is the ratio of the Emissions(kt) of Europe(developing only) in 1993 to that in 1997?
Your response must be concise. 1.44. What is the ratio of the Emissions(kt) in Indonesia in 1993 to that in 1997?
Your answer should be compact. 0.73. What is the ratio of the Emissions(kt) in Panama in 1993 to that in 1997?
Give a very brief answer. 0.93. What is the ratio of the Emissions(kt) in Europe(developing only) in 1993 to that in 1998?
Offer a terse response. 1.44. What is the ratio of the Emissions(kt) in Indonesia in 1993 to that in 1998?
Provide a succinct answer. 0.66. What is the ratio of the Emissions(kt) in Madagascar in 1993 to that in 1998?
Offer a very short reply. 1.11. What is the ratio of the Emissions(kt) in Panama in 1993 to that in 1998?
Keep it short and to the point. 0.88. What is the ratio of the Emissions(kt) of Europe(developing only) in 1993 to that in 1999?
Make the answer very short. 1.51. What is the ratio of the Emissions(kt) of Indonesia in 1993 to that in 1999?
Your response must be concise. 0.57. What is the ratio of the Emissions(kt) of Panama in 1993 to that in 1999?
Your answer should be compact. 0.88. What is the ratio of the Emissions(kt) of Europe(developing only) in 1994 to that in 1995?
Your answer should be compact. 1.05. What is the ratio of the Emissions(kt) in Indonesia in 1994 to that in 1995?
Keep it short and to the point. 1.06. What is the ratio of the Emissions(kt) of Madagascar in 1994 to that in 1995?
Your response must be concise. 1.29. What is the ratio of the Emissions(kt) in Panama in 1994 to that in 1995?
Your answer should be very brief. 1.5. What is the ratio of the Emissions(kt) in Europe(developing only) in 1994 to that in 1996?
Your answer should be very brief. 1.13. What is the ratio of the Emissions(kt) of Indonesia in 1994 to that in 1996?
Make the answer very short. 0.97. What is the ratio of the Emissions(kt) of Panama in 1994 to that in 1996?
Your answer should be very brief. 0.54. What is the ratio of the Emissions(kt) in Europe(developing only) in 1994 to that in 1997?
Provide a short and direct response. 1.27. What is the ratio of the Emissions(kt) of Indonesia in 1994 to that in 1997?
Give a very brief answer. 0.91. What is the ratio of the Emissions(kt) in Madagascar in 1994 to that in 1997?
Provide a succinct answer. 1. What is the ratio of the Emissions(kt) of Panama in 1994 to that in 1997?
Your response must be concise. 0.95. What is the ratio of the Emissions(kt) in Europe(developing only) in 1994 to that in 1998?
Give a very brief answer. 1.27. What is the ratio of the Emissions(kt) in Indonesia in 1994 to that in 1998?
Offer a very short reply. 0.83. What is the ratio of the Emissions(kt) of Madagascar in 1994 to that in 1998?
Give a very brief answer. 1. What is the ratio of the Emissions(kt) in Panama in 1994 to that in 1998?
Offer a terse response. 0.91. What is the ratio of the Emissions(kt) of Europe(developing only) in 1994 to that in 1999?
Provide a succinct answer. 1.33. What is the ratio of the Emissions(kt) in Indonesia in 1994 to that in 1999?
Offer a terse response. 0.72. What is the ratio of the Emissions(kt) in Panama in 1994 to that in 1999?
Offer a very short reply. 0.91. What is the ratio of the Emissions(kt) in Europe(developing only) in 1995 to that in 1996?
Provide a succinct answer. 1.07. What is the ratio of the Emissions(kt) in Indonesia in 1995 to that in 1996?
Your answer should be very brief. 0.91. What is the ratio of the Emissions(kt) in Panama in 1995 to that in 1996?
Offer a very short reply. 0.36. What is the ratio of the Emissions(kt) of Europe(developing only) in 1995 to that in 1997?
Your answer should be compact. 1.21. What is the ratio of the Emissions(kt) in Indonesia in 1995 to that in 1997?
Ensure brevity in your answer.  0.86. What is the ratio of the Emissions(kt) in Madagascar in 1995 to that in 1997?
Provide a short and direct response. 0.78. What is the ratio of the Emissions(kt) in Panama in 1995 to that in 1997?
Keep it short and to the point. 0.63. What is the ratio of the Emissions(kt) of Europe(developing only) in 1995 to that in 1998?
Keep it short and to the point. 1.2. What is the ratio of the Emissions(kt) of Indonesia in 1995 to that in 1998?
Keep it short and to the point. 0.78. What is the ratio of the Emissions(kt) in Panama in 1995 to that in 1998?
Offer a very short reply. 0.6. What is the ratio of the Emissions(kt) in Europe(developing only) in 1995 to that in 1999?
Provide a succinct answer. 1.27. What is the ratio of the Emissions(kt) of Indonesia in 1995 to that in 1999?
Provide a succinct answer. 0.68. What is the ratio of the Emissions(kt) of Panama in 1995 to that in 1999?
Keep it short and to the point. 0.6. What is the ratio of the Emissions(kt) in Europe(developing only) in 1996 to that in 1997?
Give a very brief answer. 1.13. What is the ratio of the Emissions(kt) of Indonesia in 1996 to that in 1997?
Offer a terse response. 0.94. What is the ratio of the Emissions(kt) in Madagascar in 1996 to that in 1997?
Provide a succinct answer. 0.78. What is the ratio of the Emissions(kt) in Panama in 1996 to that in 1997?
Provide a succinct answer. 1.76. What is the ratio of the Emissions(kt) of Europe(developing only) in 1996 to that in 1998?
Your answer should be compact. 1.12. What is the ratio of the Emissions(kt) in Indonesia in 1996 to that in 1998?
Offer a terse response. 0.86. What is the ratio of the Emissions(kt) of Madagascar in 1996 to that in 1998?
Give a very brief answer. 0.78. What is the ratio of the Emissions(kt) in Panama in 1996 to that in 1998?
Your response must be concise. 1.67. What is the ratio of the Emissions(kt) in Europe(developing only) in 1996 to that in 1999?
Make the answer very short. 1.18. What is the ratio of the Emissions(kt) in Indonesia in 1996 to that in 1999?
Your answer should be compact. 0.74. What is the ratio of the Emissions(kt) in Panama in 1996 to that in 1999?
Give a very brief answer. 1.67. What is the ratio of the Emissions(kt) of Europe(developing only) in 1997 to that in 1998?
Give a very brief answer. 1. What is the ratio of the Emissions(kt) of Indonesia in 1997 to that in 1998?
Ensure brevity in your answer.  0.92. What is the ratio of the Emissions(kt) in Panama in 1997 to that in 1998?
Provide a succinct answer. 0.95. What is the ratio of the Emissions(kt) in Europe(developing only) in 1997 to that in 1999?
Offer a terse response. 1.05. What is the ratio of the Emissions(kt) of Indonesia in 1997 to that in 1999?
Keep it short and to the point. 0.79. What is the ratio of the Emissions(kt) of Panama in 1997 to that in 1999?
Keep it short and to the point. 0.95. What is the ratio of the Emissions(kt) of Europe(developing only) in 1998 to that in 1999?
Offer a terse response. 1.05. What is the ratio of the Emissions(kt) in Indonesia in 1998 to that in 1999?
Give a very brief answer. 0.86. What is the ratio of the Emissions(kt) of Madagascar in 1998 to that in 1999?
Your answer should be compact. 1.5. What is the ratio of the Emissions(kt) in Panama in 1998 to that in 1999?
Keep it short and to the point. 1. What is the difference between the highest and the second highest Emissions(kt) in Europe(developing only)?
Make the answer very short. 7.23e+04. What is the difference between the highest and the second highest Emissions(kt) in Indonesia?
Provide a succinct answer. 5097.13. What is the difference between the highest and the second highest Emissions(kt) in Madagascar?
Make the answer very short. 3.67. What is the difference between the highest and the second highest Emissions(kt) of Panama?
Your answer should be very brief. 106.34. What is the difference between the highest and the lowest Emissions(kt) of Europe(developing only)?
Provide a succinct answer. 2.08e+05. What is the difference between the highest and the lowest Emissions(kt) in Indonesia?
Your answer should be very brief. 1.59e+04. What is the difference between the highest and the lowest Emissions(kt) of Madagascar?
Offer a very short reply. 14.67. What is the difference between the highest and the lowest Emissions(kt) in Panama?
Your answer should be very brief. 168.68. 